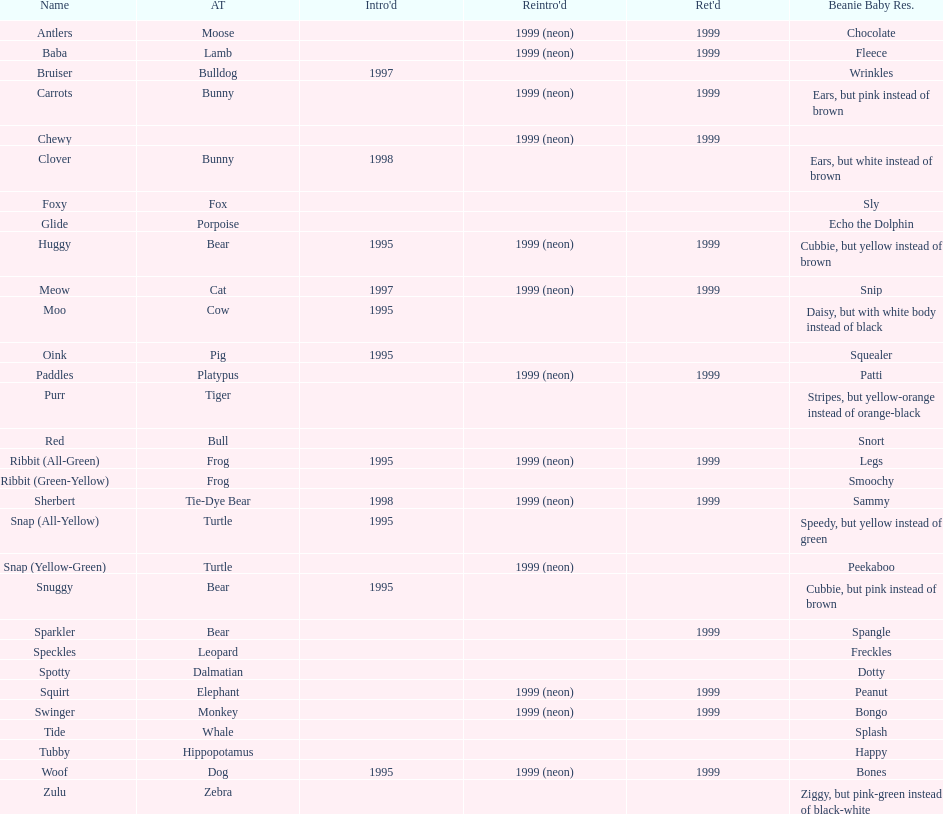Name the only pillow pal that is a dalmatian. Spotty. 